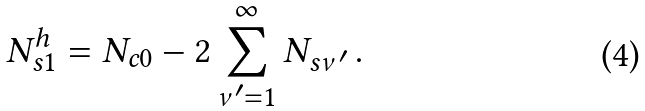<formula> <loc_0><loc_0><loc_500><loc_500>N ^ { h } _ { s 1 } = N _ { c 0 } - 2 \sum _ { \nu ^ { \prime } = 1 } ^ { \infty } N _ { s \nu ^ { \prime } } \, .</formula> 